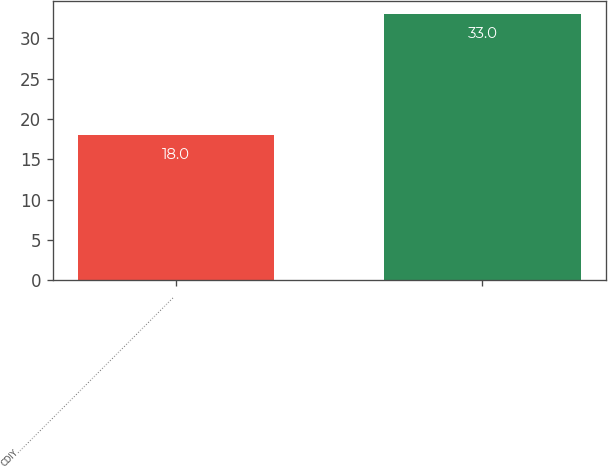Convert chart to OTSL. <chart><loc_0><loc_0><loc_500><loc_500><bar_chart><fcel>CDIY……………………………………………………………………<fcel>Unnamed: 1<nl><fcel>18<fcel>33<nl></chart> 